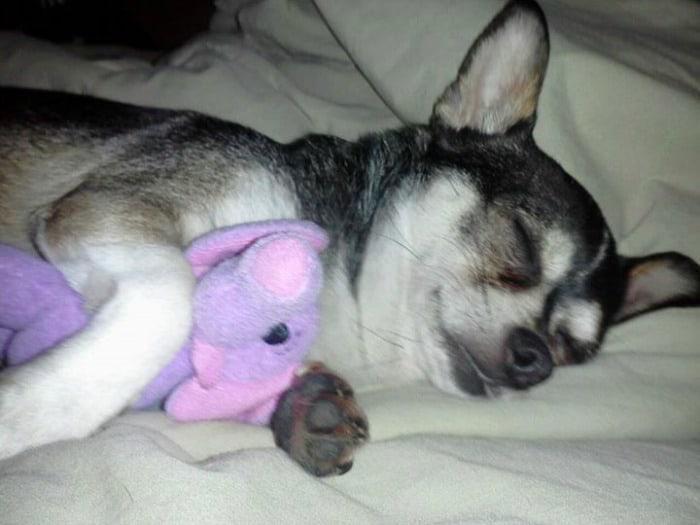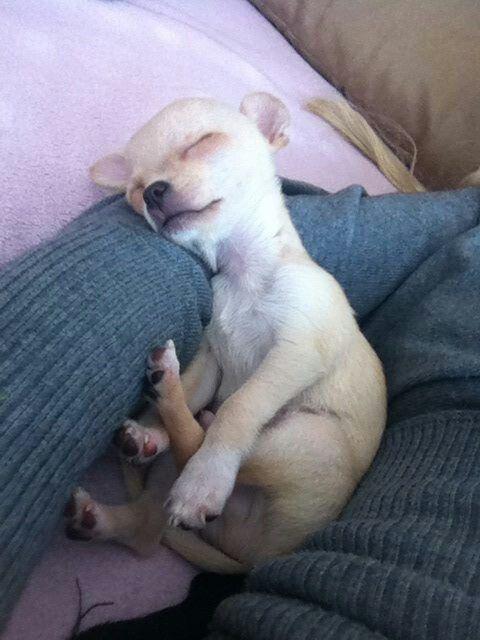The first image is the image on the left, the second image is the image on the right. Analyze the images presented: Is the assertion "Both images show a chihuahua dog in a snoozing pose, but only one dog has its eyes completely shut." valid? Answer yes or no. No. The first image is the image on the left, the second image is the image on the right. Evaluate the accuracy of this statement regarding the images: "The eyes of the dog in the image on the right are half open.". Is it true? Answer yes or no. No. 